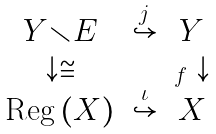<formula> <loc_0><loc_0><loc_500><loc_500>\begin{array} { c c c } Y \mathbb { r } E & \overset { j } { \hookrightarrow } & Y \\ \downarrow \cong & & _ { f } \downarrow \\ \text {Reg} \left ( X \right ) & \overset { \iota } { \hookrightarrow } & X \end{array}</formula> 